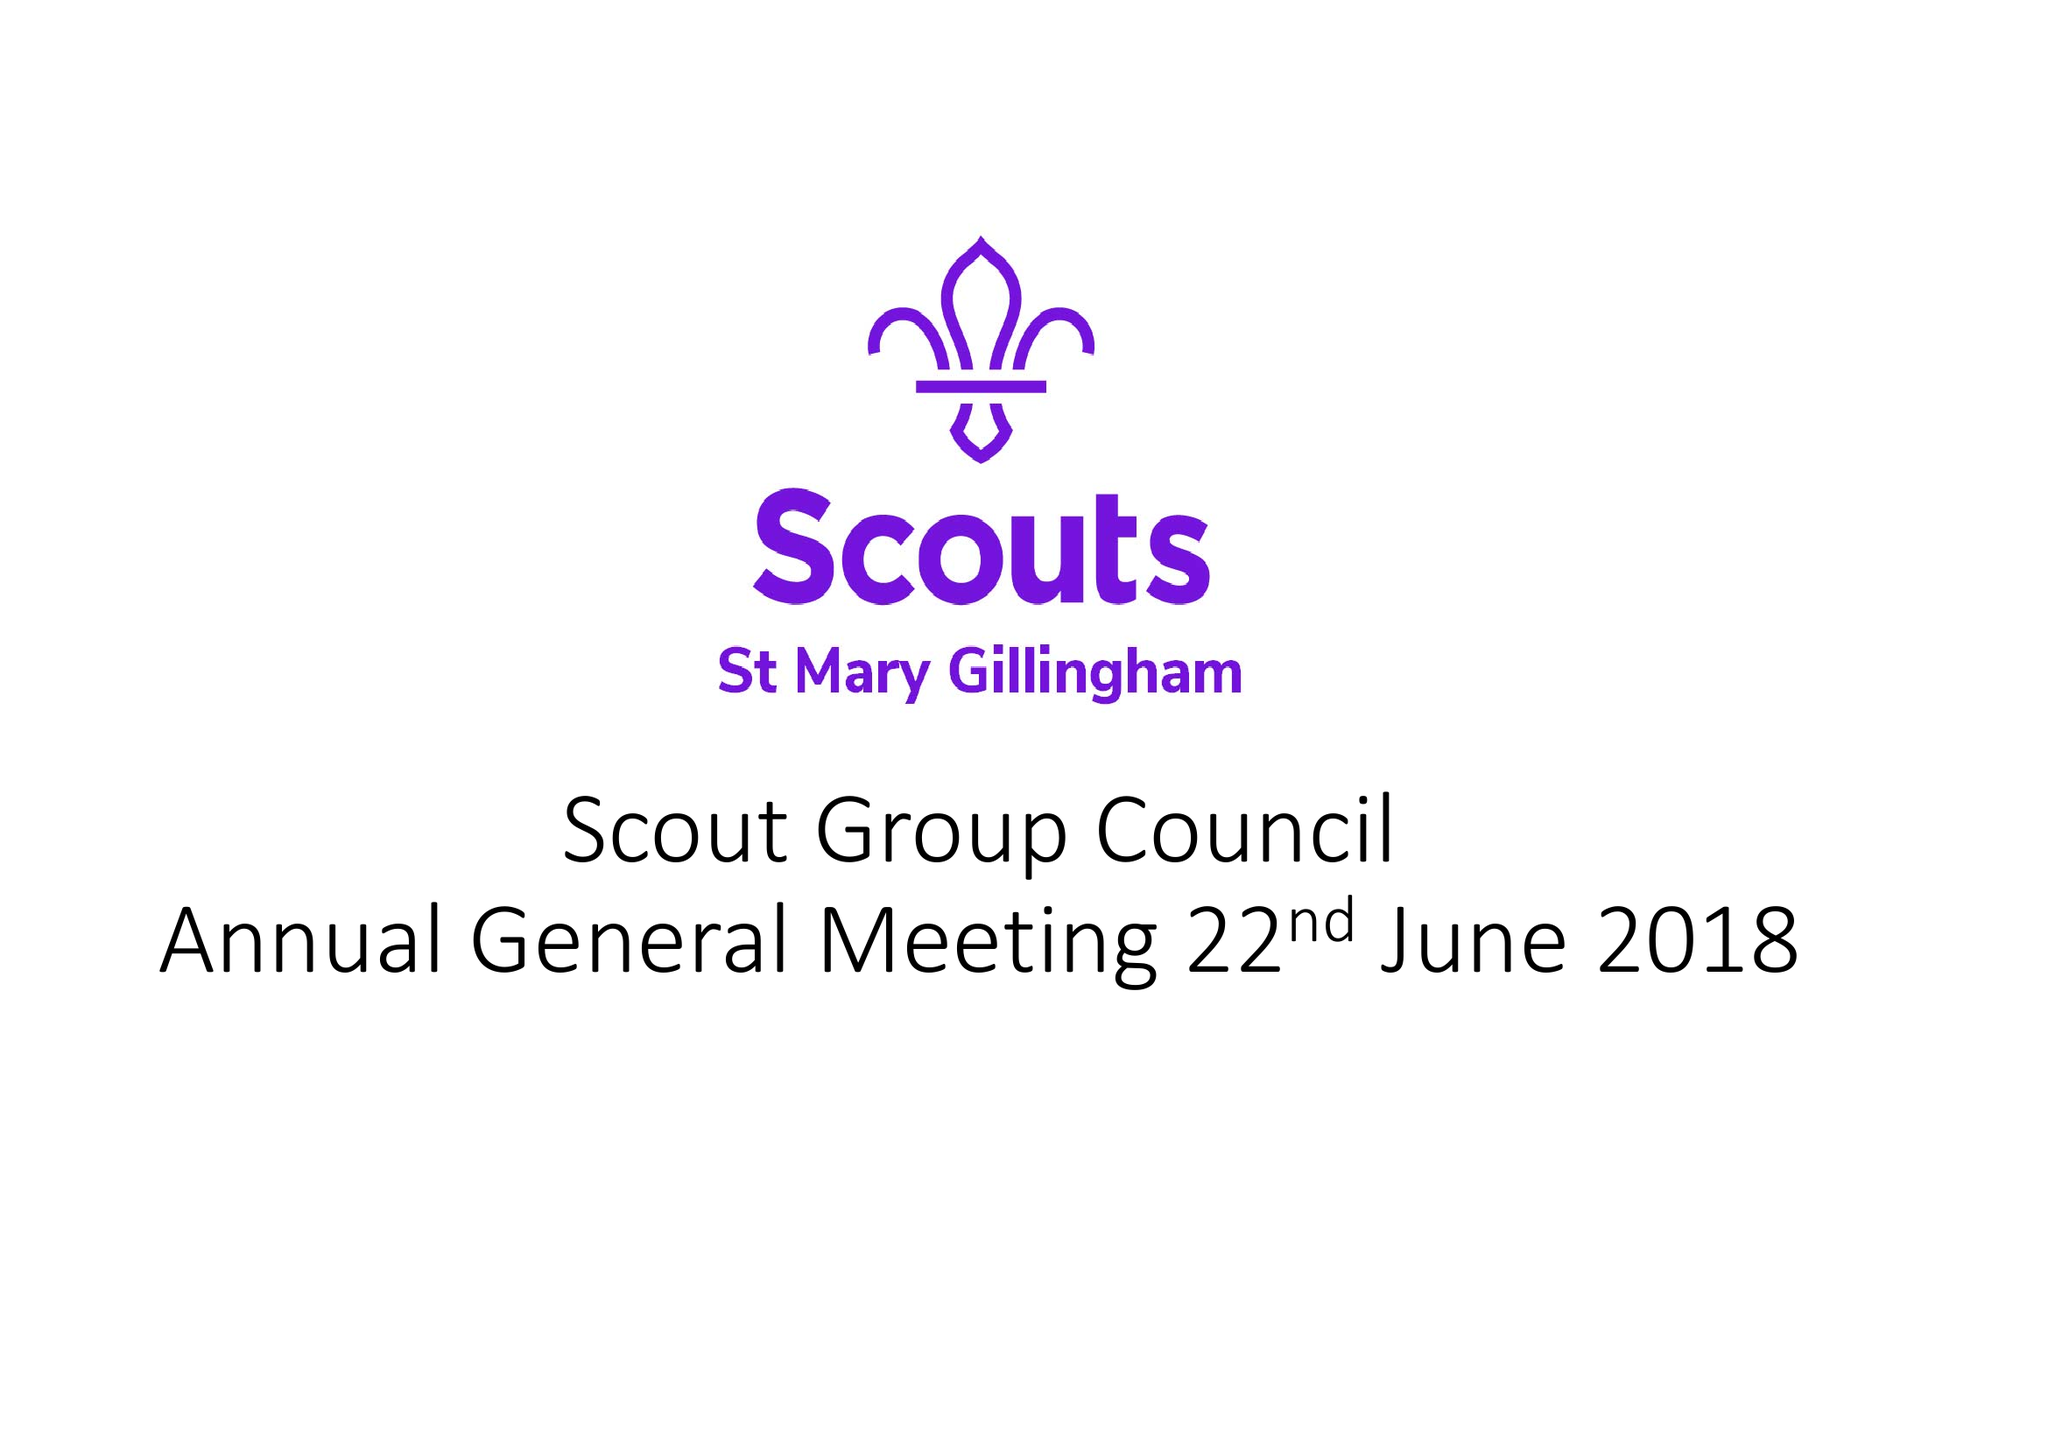What is the value for the spending_annually_in_british_pounds?
Answer the question using a single word or phrase. 28145.27 